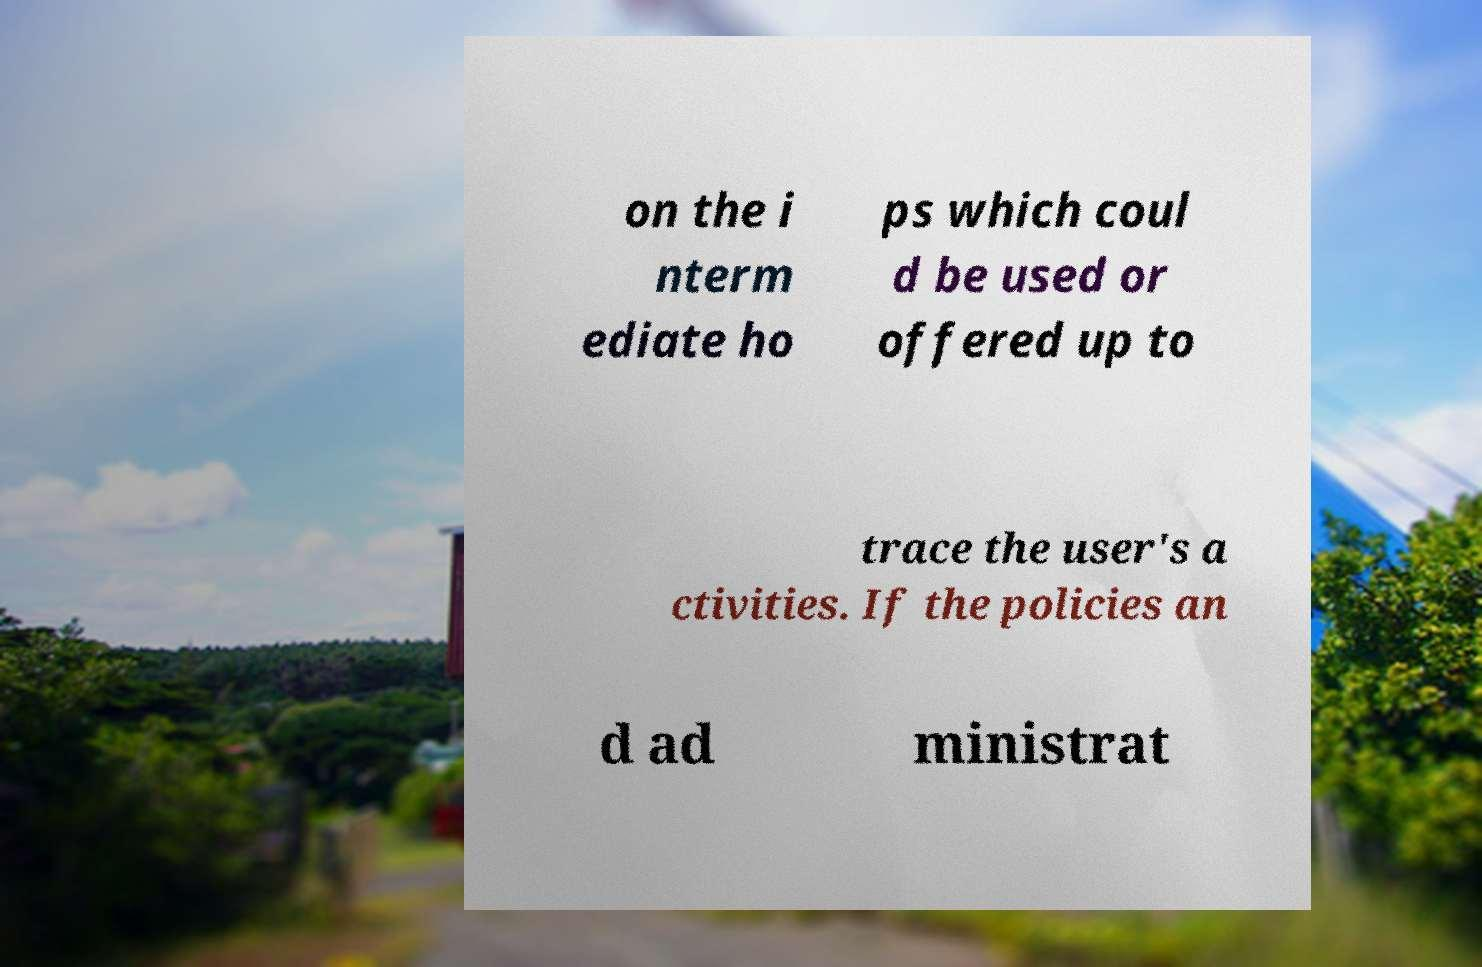Could you assist in decoding the text presented in this image and type it out clearly? on the i nterm ediate ho ps which coul d be used or offered up to trace the user's a ctivities. If the policies an d ad ministrat 